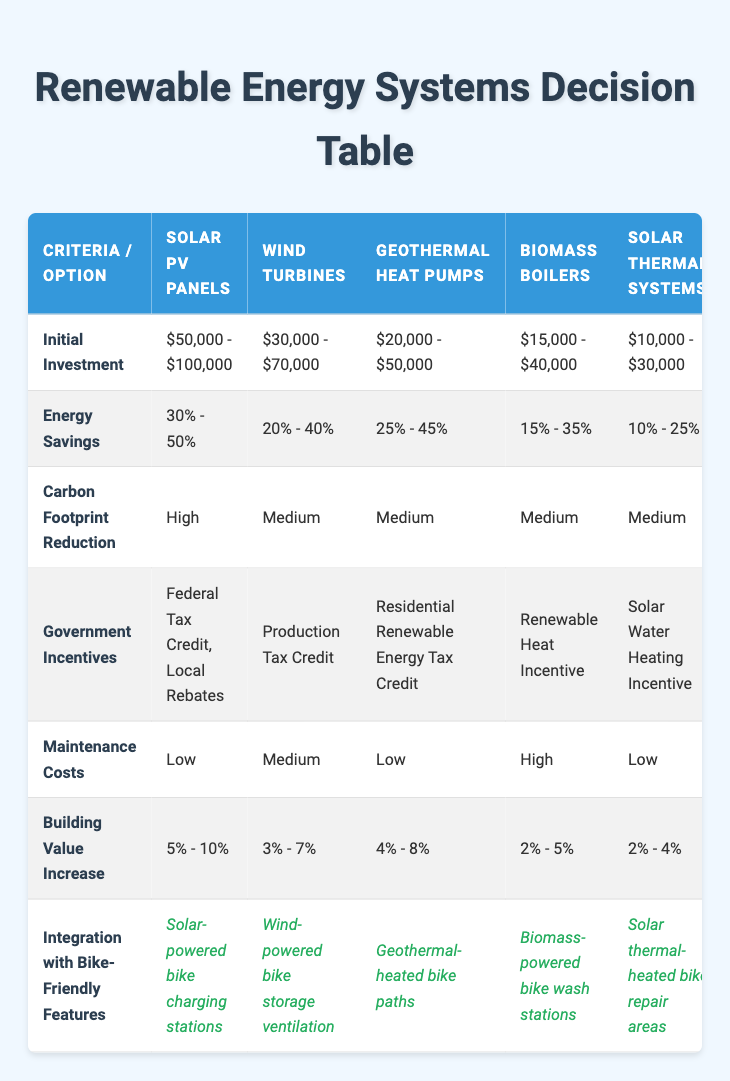What is the initial investment range for Solar PV Panels? According to the table, the initial investment for Solar PV Panels falls between $50,000 and $100,000.
Answer: $50,000 - $100,000 Which renewable energy option has the highest energy savings percentage? Looking at the energy savings column, Solar PV Panels show a range of 30% - 50%, which is higher than the others listed.
Answer: Solar PV Panels Is there a renewable energy option that has low maintenance costs? By examining the maintenance costs row, both Solar PV Panels and Geothermal Heat Pumps are marked as having low maintenance costs.
Answer: Yes What is the average increase in building value for Wind Turbines and Biomass Boilers combined? For Wind Turbines, the building value increase is 3% - 7%, and for Biomass Boilers, it is 2% - 5%. To find the average, take the midpoints: (3.5 + 4) / 2 = 3.75% and (7 + 5) / 2 = 6%. Then, averaging these values gives (3.75 + 6) / 2 = 4.875%, rounding to approximately 5%.
Answer: 5% Is integration with bike-friendly features consistent across all options? Checking the integration row, all renewable options provide bike-friendly features, indicating that integration is consistent among them.
Answer: Yes How does the carbon footprint reduction of Solar PV Panels compare to Biomass Boilers? Solar PV Panels have a high reduction, while Biomass Boilers have a medium reduction. This shows that Solar PV Panels are more effective in reducing carbon footprint than Biomass Boilers.
Answer: Higher Which renewable energy option has the lowest initial investment? From the initial investment values, Biomass Boilers have an investment range of $15,000 - $40,000, making it the lowest compared to the other options.
Answer: Biomass Boilers If you were to choose the renewable energy option with both the highest energy savings and low maintenance costs, which would it be? Checking the table, Solar PV Panels provide the highest energy savings (30% - 50%) and have low maintenance costs, making it the ideal choice based on the criteria provided.
Answer: Solar PV Panels 